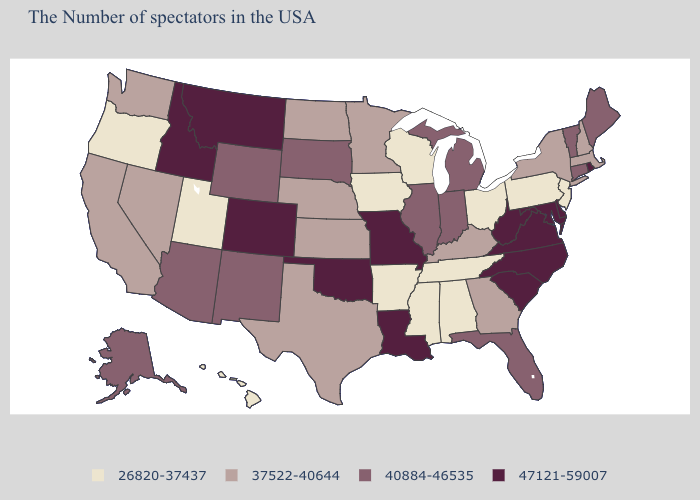What is the highest value in the MidWest ?
Keep it brief. 47121-59007. What is the lowest value in the MidWest?
Answer briefly. 26820-37437. Among the states that border New York , which have the lowest value?
Be succinct. New Jersey, Pennsylvania. Among the states that border Missouri , which have the lowest value?
Be succinct. Tennessee, Arkansas, Iowa. What is the value of Arkansas?
Be succinct. 26820-37437. Name the states that have a value in the range 37522-40644?
Quick response, please. Massachusetts, New Hampshire, New York, Georgia, Kentucky, Minnesota, Kansas, Nebraska, Texas, North Dakota, Nevada, California, Washington. Does Pennsylvania have the highest value in the Northeast?
Quick response, please. No. Name the states that have a value in the range 40884-46535?
Write a very short answer. Maine, Vermont, Connecticut, Florida, Michigan, Indiana, Illinois, South Dakota, Wyoming, New Mexico, Arizona, Alaska. How many symbols are there in the legend?
Give a very brief answer. 4. What is the highest value in the USA?
Concise answer only. 47121-59007. What is the value of Pennsylvania?
Short answer required. 26820-37437. What is the highest value in the USA?
Answer briefly. 47121-59007. What is the lowest value in the USA?
Be succinct. 26820-37437. Name the states that have a value in the range 47121-59007?
Answer briefly. Rhode Island, Delaware, Maryland, Virginia, North Carolina, South Carolina, West Virginia, Louisiana, Missouri, Oklahoma, Colorado, Montana, Idaho. Among the states that border South Dakota , which have the highest value?
Keep it brief. Montana. 